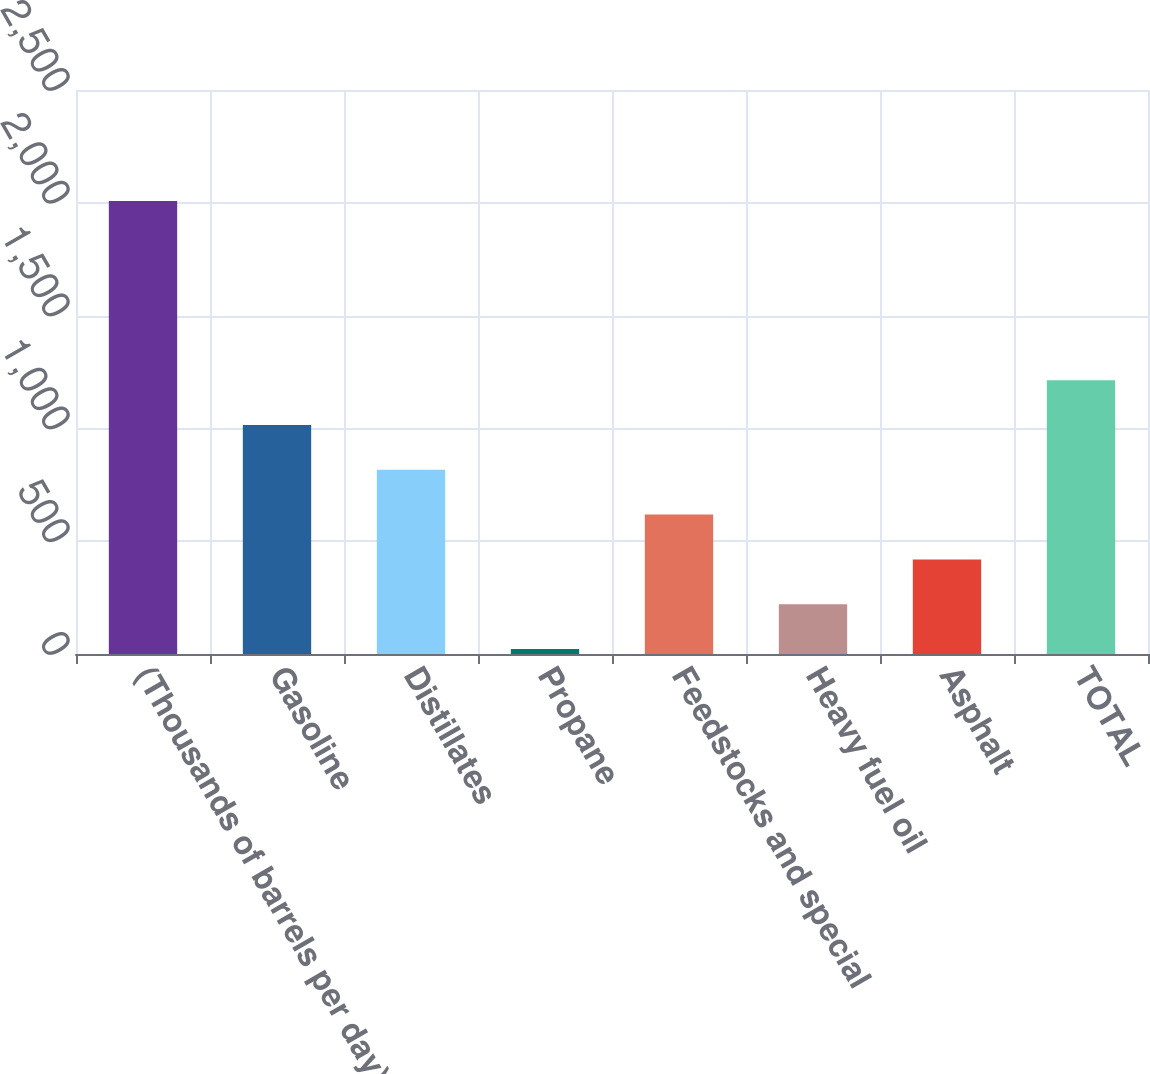<chart> <loc_0><loc_0><loc_500><loc_500><bar_chart><fcel>(Thousands of barrels per day)<fcel>Gasoline<fcel>Distillates<fcel>Propane<fcel>Feedstocks and special<fcel>Heavy fuel oil<fcel>Asphalt<fcel>TOTAL<nl><fcel>2008<fcel>1015<fcel>816.4<fcel>22<fcel>617.8<fcel>220.6<fcel>419.2<fcel>1213.6<nl></chart> 